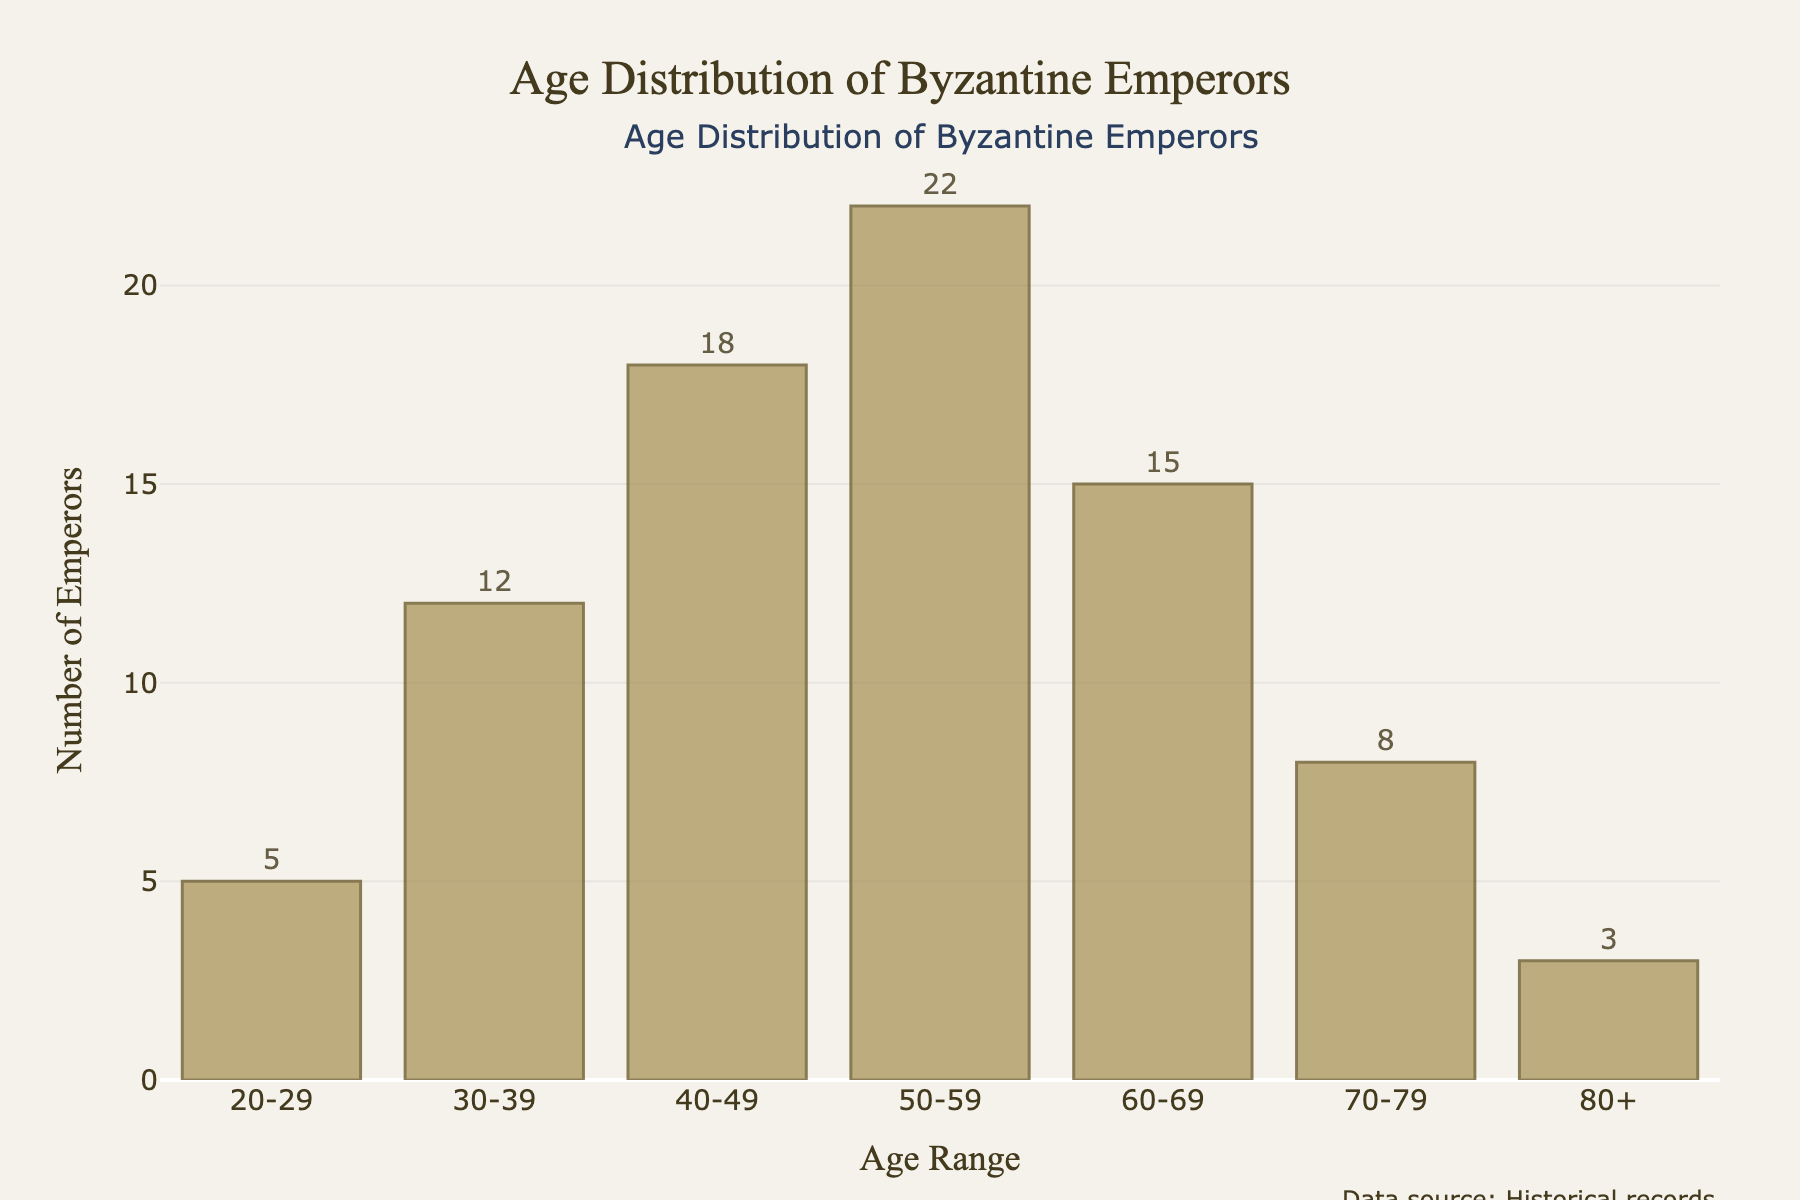What's the title of the figure? The title is prominently displayed at the top of the figure.
Answer: Age Distribution of Byzantine Emperors How many Emperors were aged between 30-39 years? The number of Emperors in each age range is annotated next to the respective bars. The bar for 30-39 years has a label showing the number 12.
Answer: 12 What's the most common age range for Byzantine Emperors? The height of each bar represents the number of Emperors. The tallest bar corresponds to the age range 50-59 years, indicating the most common age range.
Answer: 50-59 How many Emperors were aged 70 years or older? To find this, we need to sum the numbers from the bars for ages 70-79 and 80+. The number of Emperors aged 70-79 is 8, and those aged 80+ is 3. Adding these together gives 11.
Answer: 11 Compare the number of Emperors aged 40-49 to those aged 30-39. Which range had more Emperors, and by how many? The bar for 40-49 years shows 18 Emperors, and the bar for 30-39 years shows 12. Subtracting these values (18 - 12) reveals that there were 6 more Emperors aged 40-49 than 30-39.
Answer: 40-49 had 6 more Emperors What is the total number of Emperors depicted in the histogram? Add the number of Emperors in all age ranges: 5 (20-29) + 12 (30-39) + 18 (40-49) + 22 (50-59) + 15 (60-69) + 8 (70-79) + 3 (80+). This totals to 83 Emperors.
Answer: 83 Compare the number of Emperors aged 50-59 to those aged 60-69. Which range had more Emperors, and by how many? The bar for 50-59 years shows 22 Emperors, and the bar for 60-69 years shows 15. Subtracting these values (22 - 15) reveals that there were 7 more Emperors aged 50-59.
Answer: 50-59 had 7 more Emperors What proportion of Emperors lived to be at least 60 years old? To find the proportion, sum the numbers for age ranges 60-69, 70-79, and 80+: 15 + 8 + 3 = 26. Then, divide this by the total number of Emperors (83) and multiply by 100 to get the percentage: (26/83) * 100 ≈ 31.3%.
Answer: Approximately 31.3% What's the least common age range for Byzantine Emperors? The shortest bar represents the least common age range. The bar for 80+ years is the shortest with 3 Emperors.
Answer: 80+ 